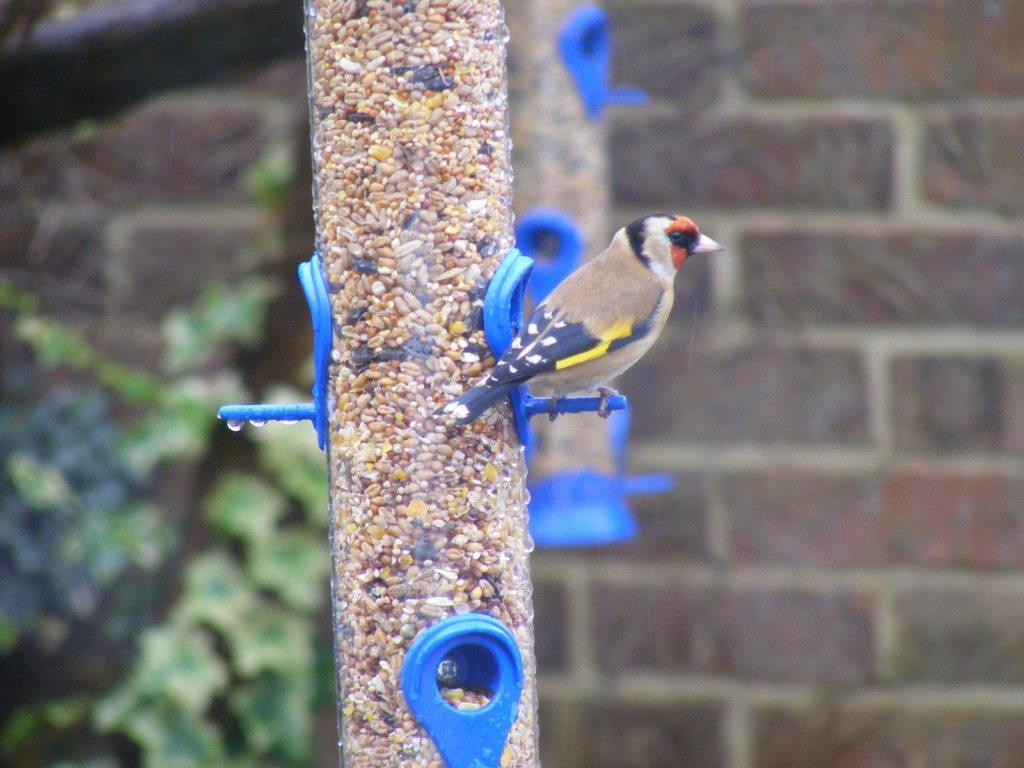In one or two sentences, can you explain what this image depicts? This i picture shows a bird on the tube and we see food for the birds in the tube and we see a wall. The bird is brown black and yellow in color. 